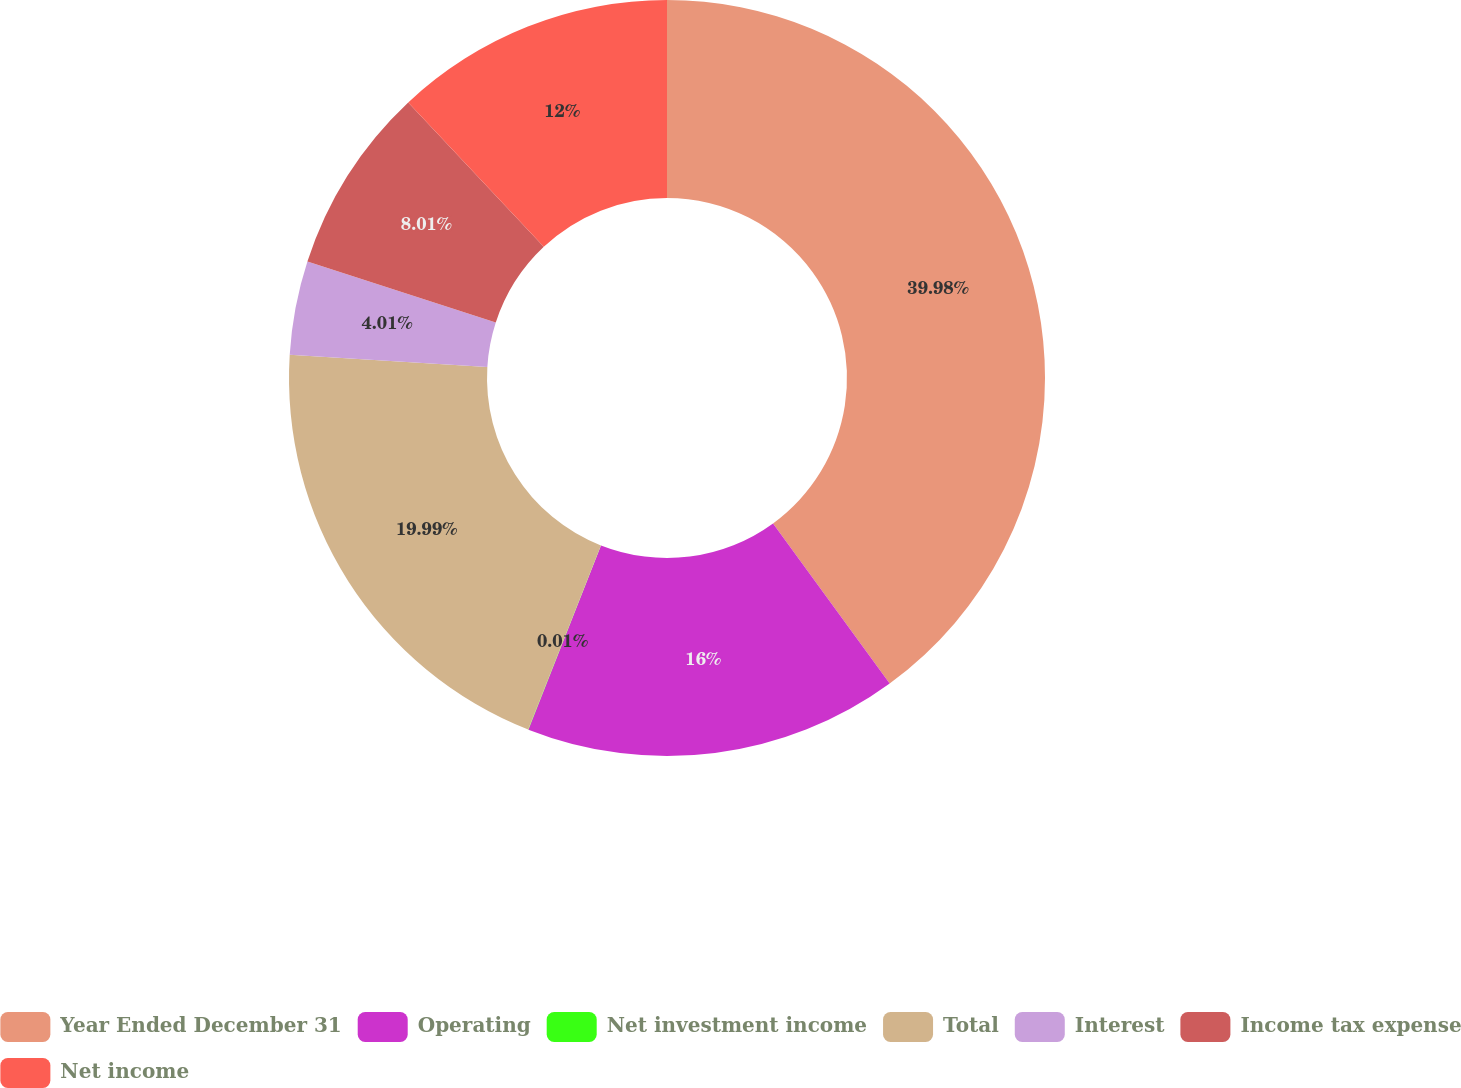Convert chart to OTSL. <chart><loc_0><loc_0><loc_500><loc_500><pie_chart><fcel>Year Ended December 31<fcel>Operating<fcel>Net investment income<fcel>Total<fcel>Interest<fcel>Income tax expense<fcel>Net income<nl><fcel>39.97%<fcel>16.0%<fcel>0.01%<fcel>19.99%<fcel>4.01%<fcel>8.01%<fcel>12.0%<nl></chart> 